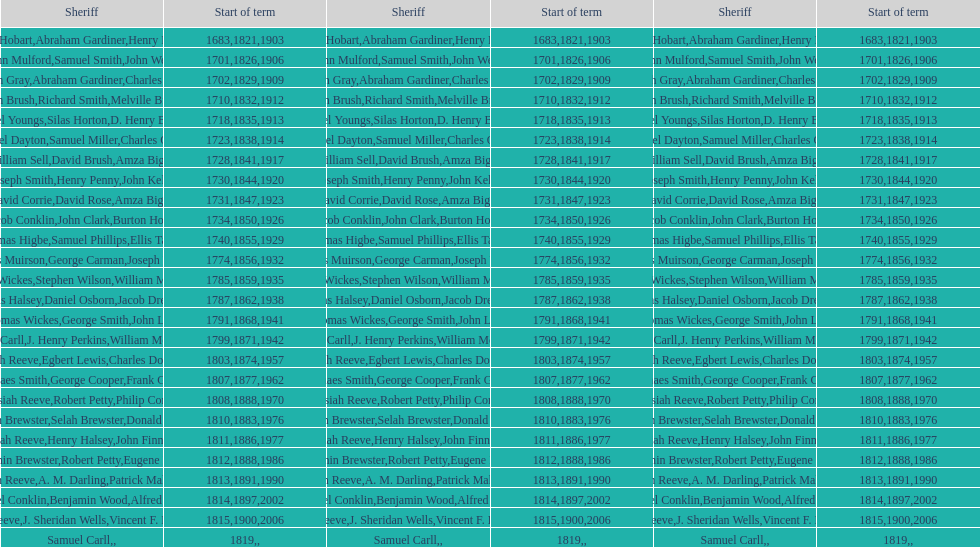When did the primary sheriff's term begin? 1683. 